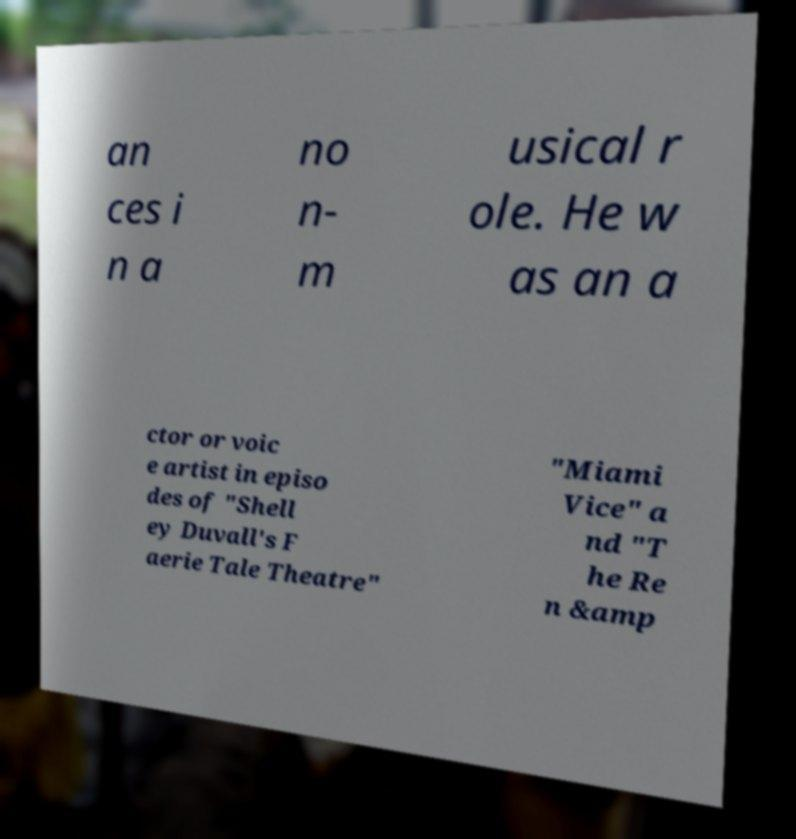For documentation purposes, I need the text within this image transcribed. Could you provide that? an ces i n a no n- m usical r ole. He w as an a ctor or voic e artist in episo des of "Shell ey Duvall's F aerie Tale Theatre" "Miami Vice" a nd "T he Re n &amp 